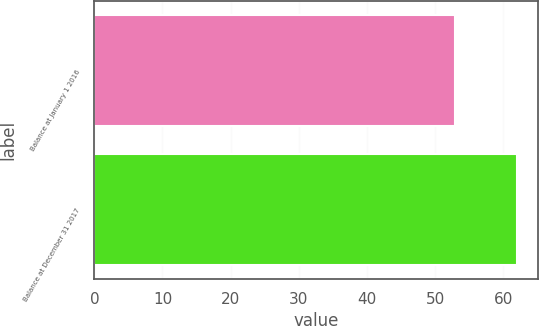Convert chart to OTSL. <chart><loc_0><loc_0><loc_500><loc_500><bar_chart><fcel>Balance at January 1 2016<fcel>Balance at December 31 2017<nl><fcel>53<fcel>62<nl></chart> 